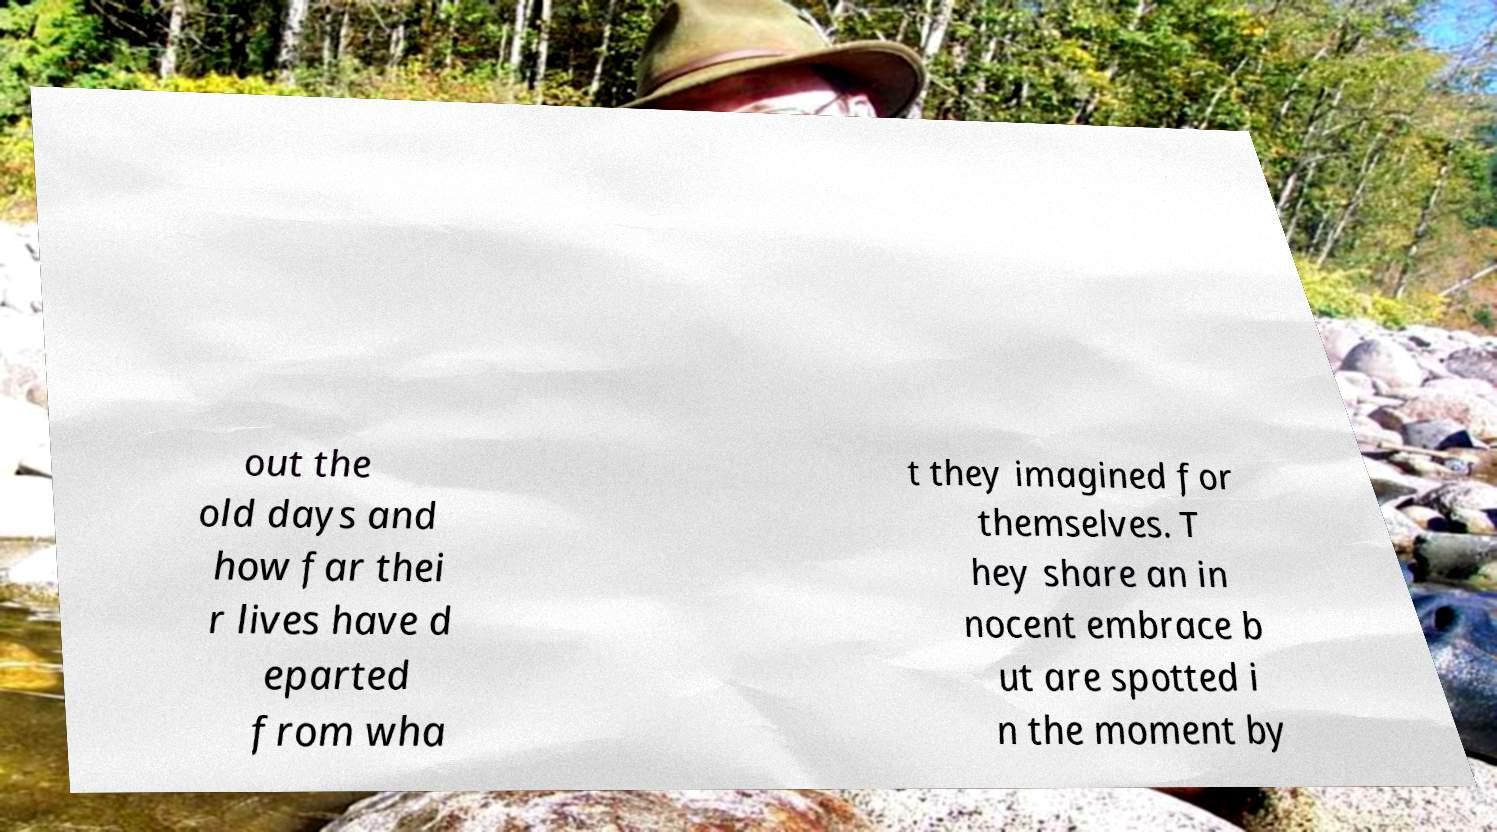What messages or text are displayed in this image? I need them in a readable, typed format. out the old days and how far thei r lives have d eparted from wha t they imagined for themselves. T hey share an in nocent embrace b ut are spotted i n the moment by 